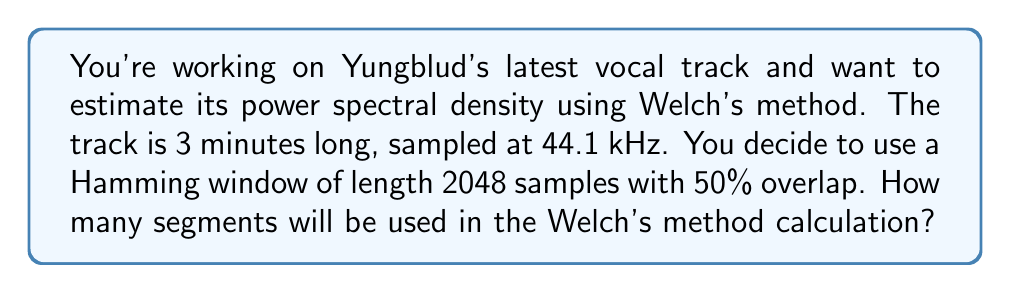Show me your answer to this math problem. To solve this problem, we need to follow these steps:

1. Calculate the total number of samples in the track:
   $$N_{total} = \text{duration} \times \text{sampling rate}$$
   $$N_{total} = 3 \text{ min} \times 60 \text{ s/min} \times 44100 \text{ samples/s} = 7,938,000 \text{ samples}$$

2. Determine the number of samples in each segment:
   Window length = 2048 samples

3. Calculate the overlap in samples:
   $$\text{Overlap} = 50\% \times 2048 = 1024 \text{ samples}$$

4. Calculate the number of new samples in each segment:
   $$N_{new} = \text{Window length} - \text{Overlap} = 2048 - 1024 = 1024 \text{ samples}$$

5. Calculate the number of segments:
   $$N_{segments} = \left\lfloor\frac{N_{total} - \text{Overlap}}{N_{new}}\right\rfloor$$
   
   Where $\lfloor \cdot \rfloor$ denotes the floor function.

   $$N_{segments} = \left\lfloor\frac{7,938,000 - 1024}{1024}\right\rfloor = \left\lfloor 7,749.53125\right\rfloor = 7,749$$

Therefore, 7,749 segments will be used in the Welch's method calculation.
Answer: 7,749 segments 